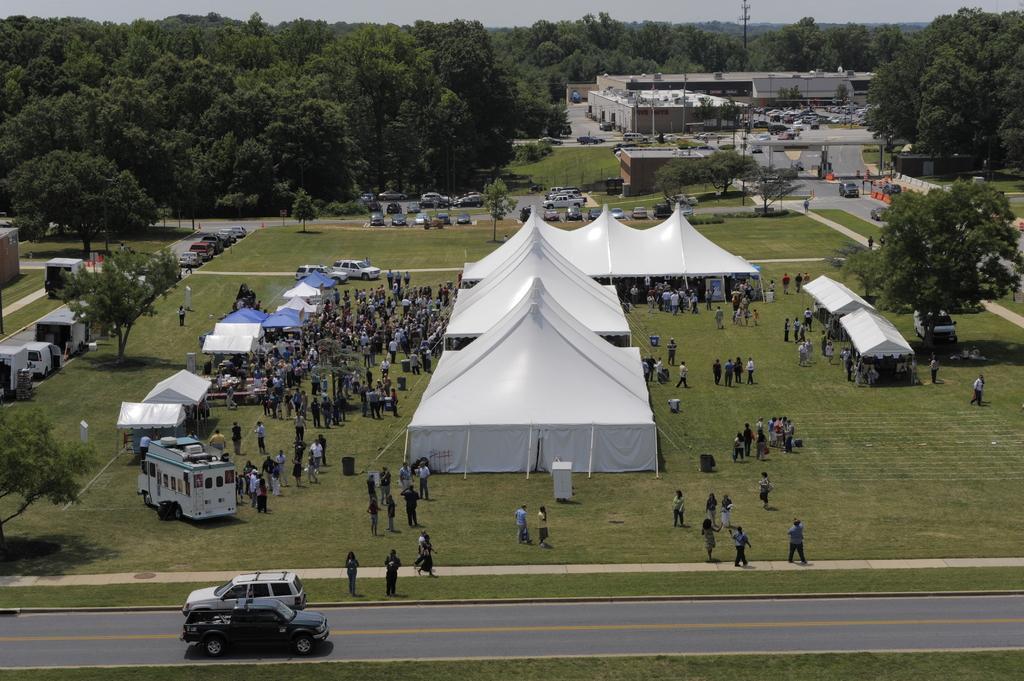In one or two sentences, can you explain what this image depicts? There are people, vehicles and people on the grassland in the foreground area of the image, there are trees, vehicles, buildings, pole and the sky in the background. 